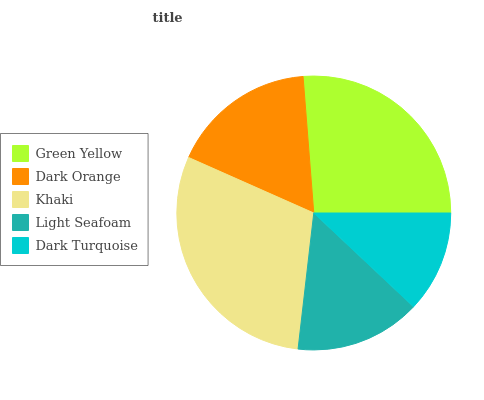Is Dark Turquoise the minimum?
Answer yes or no. Yes. Is Khaki the maximum?
Answer yes or no. Yes. Is Dark Orange the minimum?
Answer yes or no. No. Is Dark Orange the maximum?
Answer yes or no. No. Is Green Yellow greater than Dark Orange?
Answer yes or no. Yes. Is Dark Orange less than Green Yellow?
Answer yes or no. Yes. Is Dark Orange greater than Green Yellow?
Answer yes or no. No. Is Green Yellow less than Dark Orange?
Answer yes or no. No. Is Dark Orange the high median?
Answer yes or no. Yes. Is Dark Orange the low median?
Answer yes or no. Yes. Is Dark Turquoise the high median?
Answer yes or no. No. Is Dark Turquoise the low median?
Answer yes or no. No. 